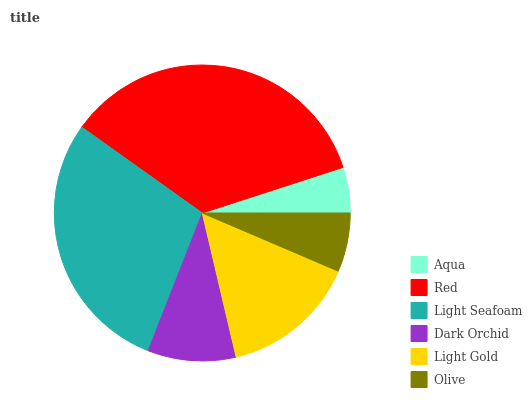Is Aqua the minimum?
Answer yes or no. Yes. Is Red the maximum?
Answer yes or no. Yes. Is Light Seafoam the minimum?
Answer yes or no. No. Is Light Seafoam the maximum?
Answer yes or no. No. Is Red greater than Light Seafoam?
Answer yes or no. Yes. Is Light Seafoam less than Red?
Answer yes or no. Yes. Is Light Seafoam greater than Red?
Answer yes or no. No. Is Red less than Light Seafoam?
Answer yes or no. No. Is Light Gold the high median?
Answer yes or no. Yes. Is Dark Orchid the low median?
Answer yes or no. Yes. Is Aqua the high median?
Answer yes or no. No. Is Red the low median?
Answer yes or no. No. 